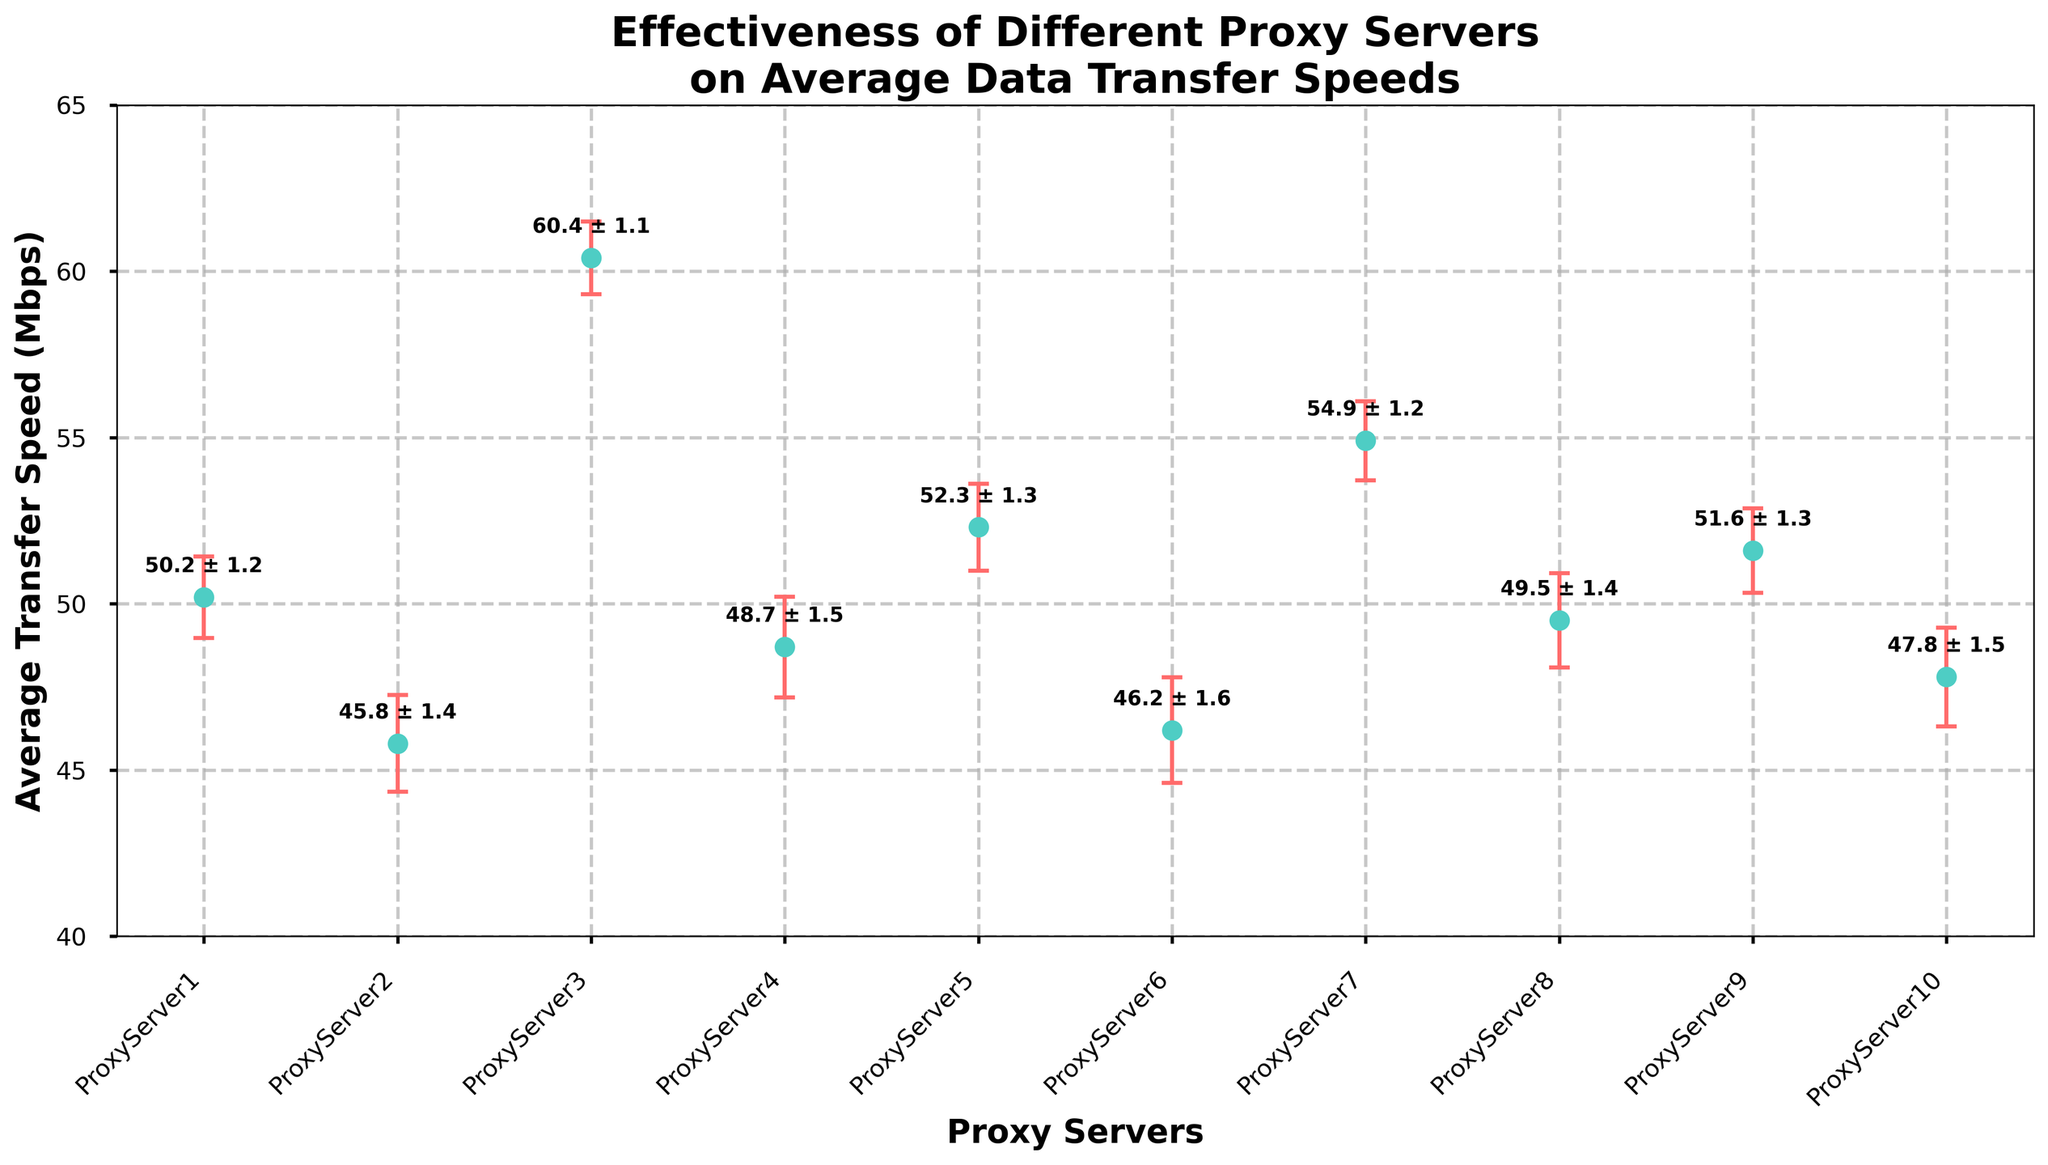What's the maximum average transfer speed among all the proxy servers? The highest point on the y-axis represents the maximum average transfer speed which corresponds to ProxyServer3_NordVPN.
Answer: 60.4 Mbps Which proxy server has the smallest error variance in average transfer speed? The smallest error bar indicates the lowest variance, which is associated with ProxyServer3_NordVPN.
Answer: ProxyServer3_NordVPN What's the range of average transfer speeds across all proxy servers? Find the difference between the highest and lowest average transfer speeds. The lowest is 45.8 Mbps (ProxyServer2_HideMyAss), and the highest is 60.4 Mbps (ProxyServer3_NordVPN). The range is 60.4 - 45.8 = 14.6 Mbps.
Answer: 14.6 Mbps Compare the average transfer speeds of ProxyServer7_HotspotShield and ProxyServer4_ExpressVPN. Which one is higher, and by how much? ProxyServer7_HotspotShield has an average speed of 54.9 Mbps, and ProxyServer4_ExpressVPN has 48.7 Mbps. The difference is 54.9 - 48.7 = 6.2 Mbps.
Answer: ProxyServer7_HotspotShield, 6.2 Mbps What’s the average of the average transfer speeds of ProxyServer5_CyberGhost and ProxyServer8_Browsec? Calculate the average of their speeds: (52.3 + 49.5) / 2 = 101.8 / 2 = 50.9 Mbps.
Answer: 50.9 Mbps Which proxy server has the largest error variance in average transfer speed? The largest error bar indicates the highest variance, which corresponds to ProxyServer6_TunnelBear.
Answer: ProxyServer6_TunnelBear According to the figure, which proxy server has an average transfer speed closest to 50 Mbps? Among the proxy servers, ProxyServer1_ProxyMesh with an average speed of 50.2 Mbps is closest to 50 Mbps.
Answer: ProxyServer1_ProxyMesh Which proxy servers have average transfer speeds greater than 50 Mbps but less than 55 Mbps? ProxyServer1_ProxyMesh (50.2 Mbps), ProxyServer5_CyberGhost (52.3 Mbps), ProxyServer9_Surfshark (51.6 Mbps), and ProxyServer7_HotspotShield (54.9 Mbps) fall within this range.
Answer: ProxyServer1_ProxyMesh, ProxyServer5_CyberGhost, ProxyServer9_Surfshark, ProxyServer7_HotspotShield What's the total sum of the average transfer speeds for all proxy servers? Sum all average transfer speeds: 50.2 + 45.8 + 60.4 + 48.7 + 52.3 + 46.2 + 54.9 + 49.5 + 51.6 + 47.8 = 507.4 Mbps.
Answer: 507.4 Mbps 